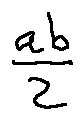Convert formula to latex. <formula><loc_0><loc_0><loc_500><loc_500>\frac { a b } { 2 }</formula> 